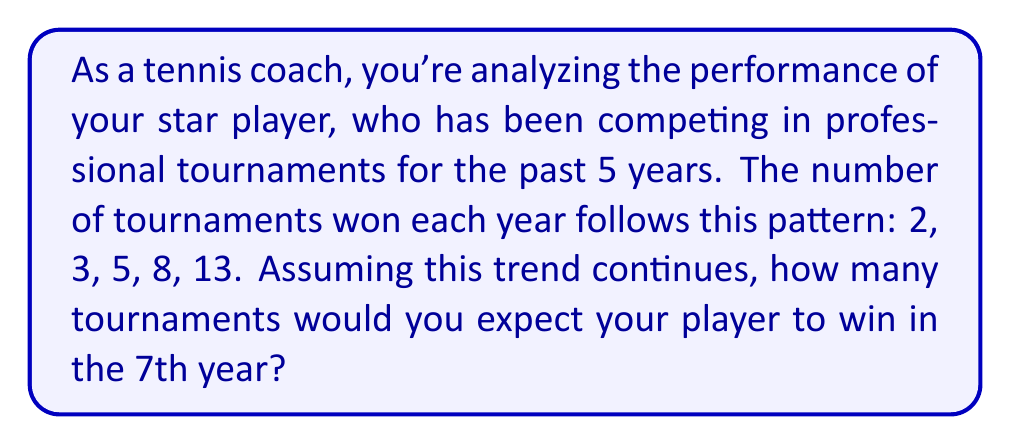Give your solution to this math problem. To solve this problem, we need to recognize the pattern in the given data and use time series analysis to forecast future values. Let's approach this step-by-step:

1) First, let's examine the sequence: 2, 3, 5, 8, 13

2) We can calculate the differences between consecutive terms:
   3 - 2 = 1
   5 - 3 = 2
   8 - 5 = 3
   13 - 8 = 5

3) We notice that these differences form another sequence: 1, 2, 3, 5

4) This new sequence is recognizable as the beginning of the Fibonacci sequence, where each number is the sum of the two preceding ones.

5) Given this pattern, we can predict the next two terms in our original sequence:
   Next term (6th year): 13 + 8 = 21
   Next term (7th year): 21 + 13 = 34

6) We can verify this using the general formula for the Fibonacci sequence:

   $$F_n = F_{n-1} + F_{n-2}$$

   Where $F_n$ is the nth term in the sequence.

7) In our case, the sequence is offset by one term, so the 7th year corresponds to the 8th Fibonacci number.

8) We can also express this using the closed-form formula for Fibonacci numbers:

   $$F_n = \frac{\phi^n - (-\phi)^{-n}}{\sqrt{5}}$$

   Where $\phi = \frac{1+\sqrt{5}}{2}$ is the golden ratio.

9) Plugging in n = 8:

   $$F_8 = \frac{\phi^8 - (-\phi)^{-8}}{\sqrt{5}} \approx 34$$

Therefore, based on this analysis, we would expect the player to win 34 tournaments in the 7th year if the trend continues.
Answer: 34 tournaments 